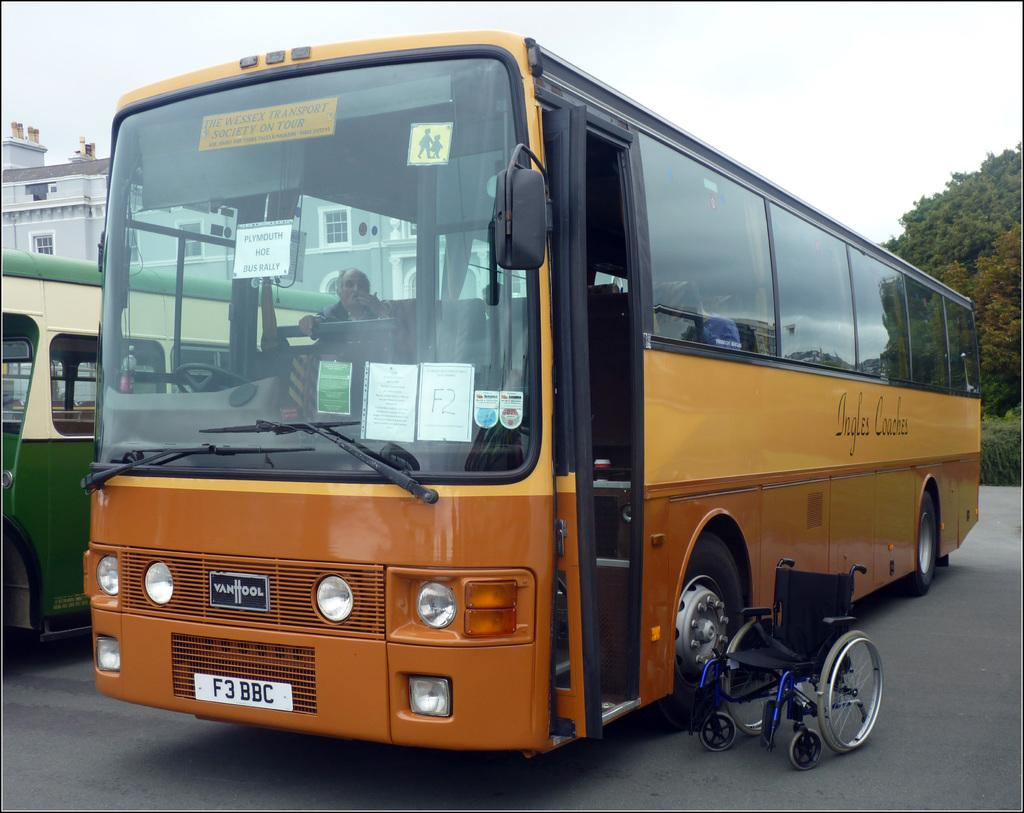<image>
Describe the image concisely. A wheelchair sits outside an Ingles Coaches bus. 